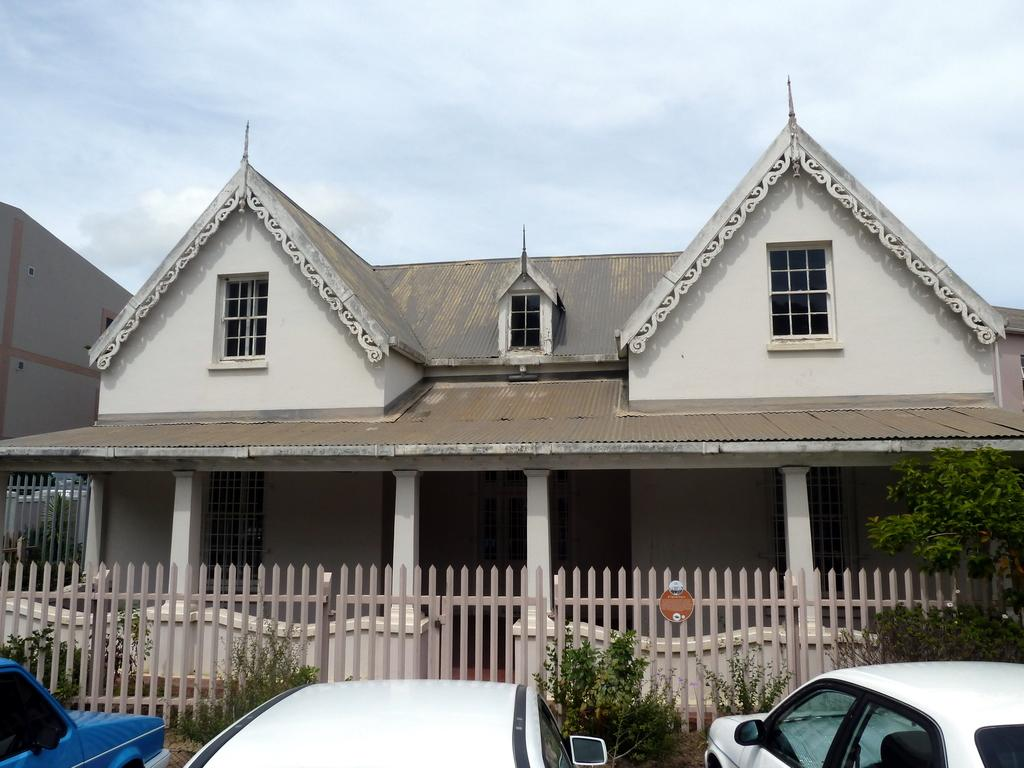What types of vehicles are in the image? The image contains vehicles, but the specific types cannot be determined from the provided facts. What is the purpose of the fence in the image? The purpose of the fence in the image cannot be determined from the provided facts. What types of plants are in the image? The image contains plants, but the specific types cannot be determined from the provided facts. What types of trees are in the image? The image contains trees, but the specific types cannot be determined from the provided facts. What objects are in the image? The image contains objects, but the specific types cannot be determined from the provided facts. What types of buildings are in the background of the image? The image contains buildings in the background, but the specific types cannot be determined from the provided facts. What is visible in the sky in the background of the image? The sky is visible in the background of the image, but the specific weather or atmospheric conditions cannot be determined from the provided facts. How many beggars are visible in the image? There are no beggars present in the image. What type of beef is being cooked in the image? There is no beef present in the image. 